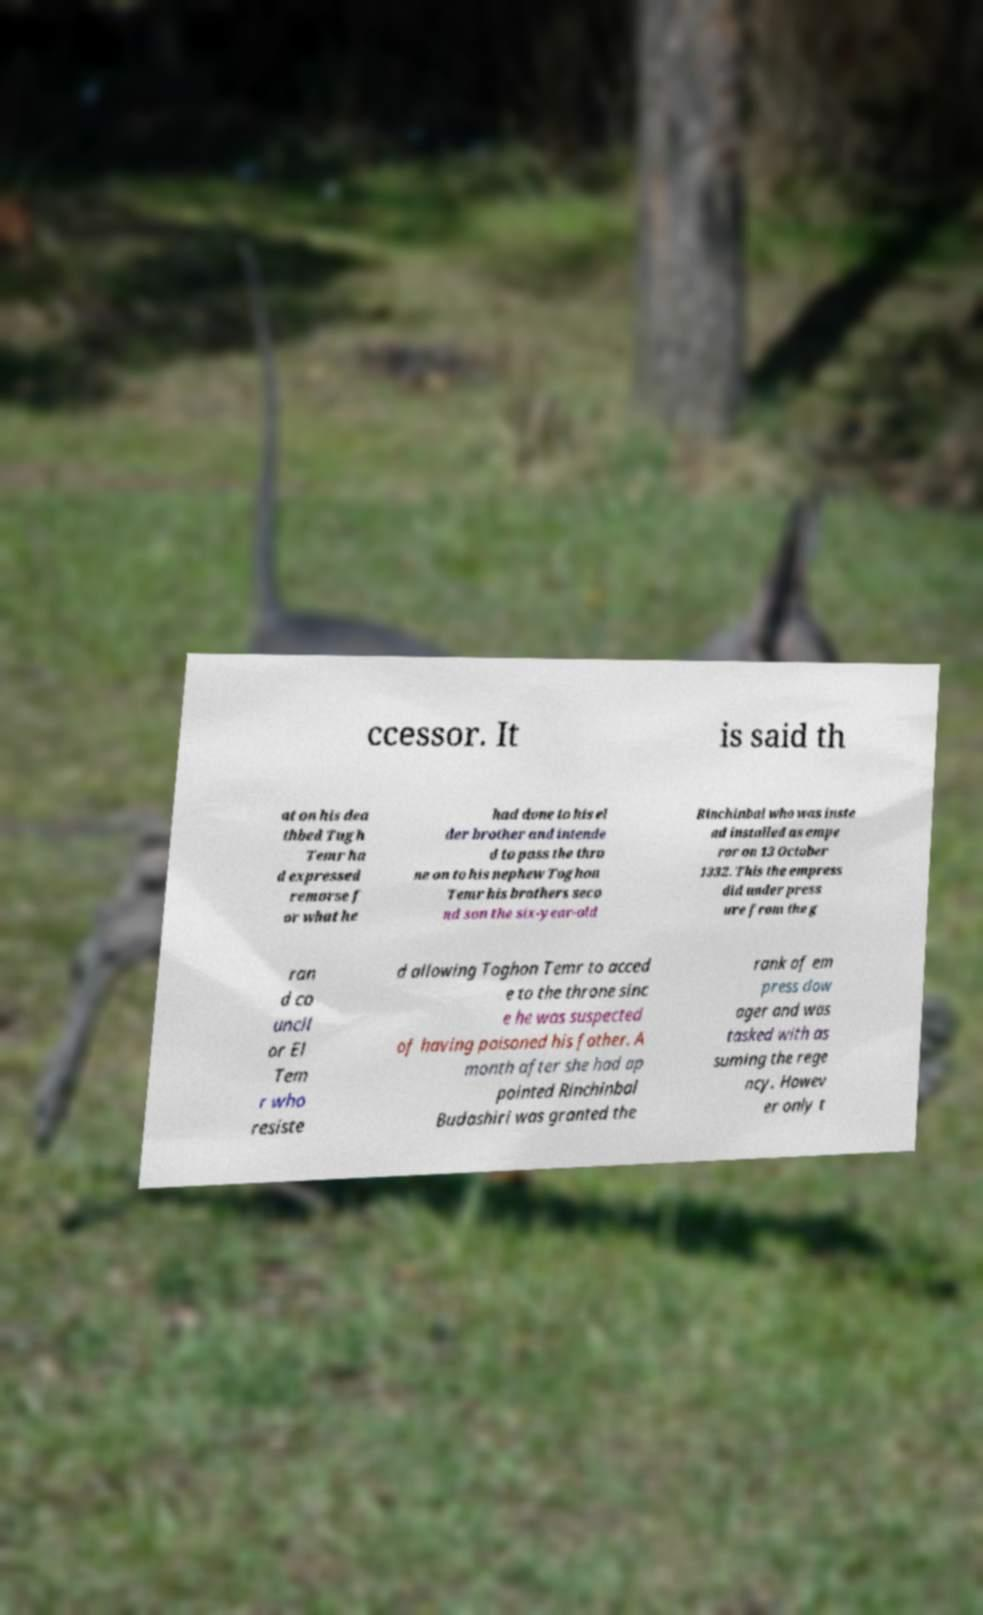Please identify and transcribe the text found in this image. ccessor. It is said th at on his dea thbed Tugh Temr ha d expressed remorse f or what he had done to his el der brother and intende d to pass the thro ne on to his nephew Toghon Temr his brothers seco nd son the six-year-old Rinchinbal who was inste ad installed as empe ror on 13 October 1332. This the empress did under press ure from the g ran d co uncil or El Tem r who resiste d allowing Toghon Temr to acced e to the throne sinc e he was suspected of having poisoned his father. A month after she had ap pointed Rinchinbal Budashiri was granted the rank of em press dow ager and was tasked with as suming the rege ncy. Howev er only t 